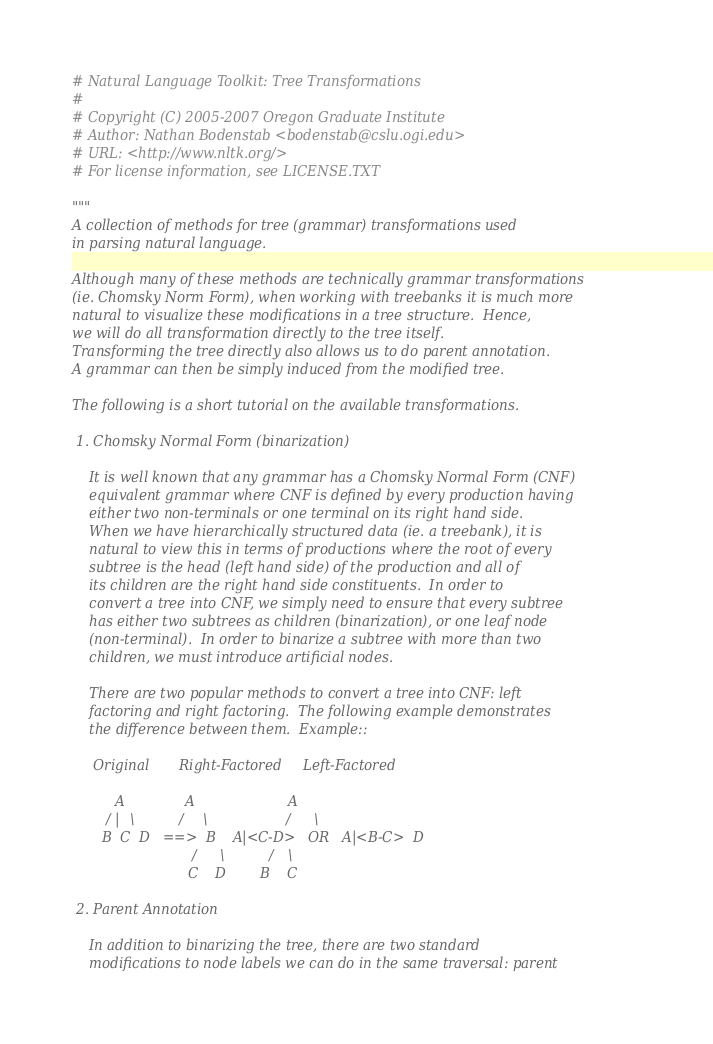Convert code to text. <code><loc_0><loc_0><loc_500><loc_500><_Python_># Natural Language Toolkit: Tree Transformations
#
# Copyright (C) 2005-2007 Oregon Graduate Institute
# Author: Nathan Bodenstab <bodenstab@cslu.ogi.edu>
# URL: <http://www.nltk.org/>
# For license information, see LICENSE.TXT

"""
A collection of methods for tree (grammar) transformations used
in parsing natural language.

Although many of these methods are technically grammar transformations
(ie. Chomsky Norm Form), when working with treebanks it is much more
natural to visualize these modifications in a tree structure.  Hence,
we will do all transformation directly to the tree itself.
Transforming the tree directly also allows us to do parent annotation.
A grammar can then be simply induced from the modified tree.

The following is a short tutorial on the available transformations.

 1. Chomsky Normal Form (binarization)

    It is well known that any grammar has a Chomsky Normal Form (CNF)
    equivalent grammar where CNF is defined by every production having
    either two non-terminals or one terminal on its right hand side.
    When we have hierarchically structured data (ie. a treebank), it is
    natural to view this in terms of productions where the root of every
    subtree is the head (left hand side) of the production and all of
    its children are the right hand side constituents.  In order to
    convert a tree into CNF, we simply need to ensure that every subtree
    has either two subtrees as children (binarization), or one leaf node
    (non-terminal).  In order to binarize a subtree with more than two
    children, we must introduce artificial nodes.

    There are two popular methods to convert a tree into CNF: left
    factoring and right factoring.  The following example demonstrates
    the difference between them.  Example::

     Original       Right-Factored     Left-Factored

          A              A                      A
        / | \          /   \                  /   \
       B  C  D   ==>  B    A|<C-D>   OR   A|<B-C>  D
                            /  \          /  \
                           C    D        B    C

 2. Parent Annotation

    In addition to binarizing the tree, there are two standard
    modifications to node labels we can do in the same traversal: parent</code> 